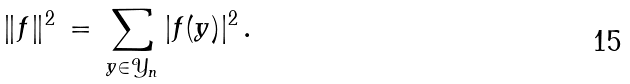Convert formula to latex. <formula><loc_0><loc_0><loc_500><loc_500>\| f \| ^ { 2 } \, = \, \sum _ { y \in \mathcal { Y } _ { n } } | f ( y ) | ^ { 2 } \, .</formula> 